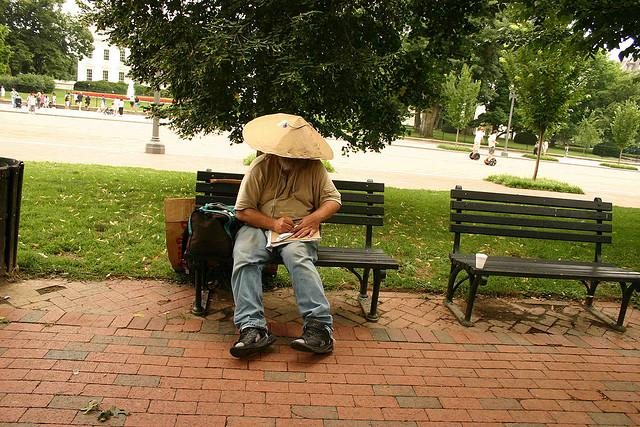What purpose does the large disk on this person's head serve most here?

Choices:
A) rain protection
B) moon
C) sun
D) hiding sun 